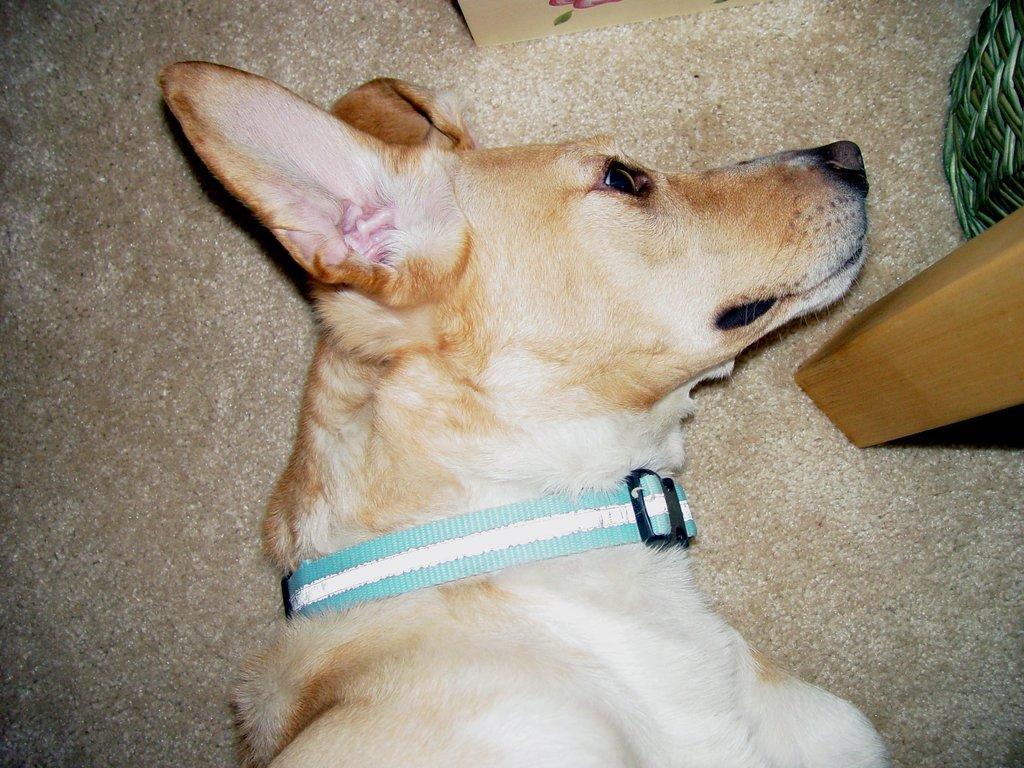In one or two sentences, can you explain what this image depicts? In the image we can see a dog, white and pale brown in color. Here we can see dog belt, floor, wooden pole and basket. 